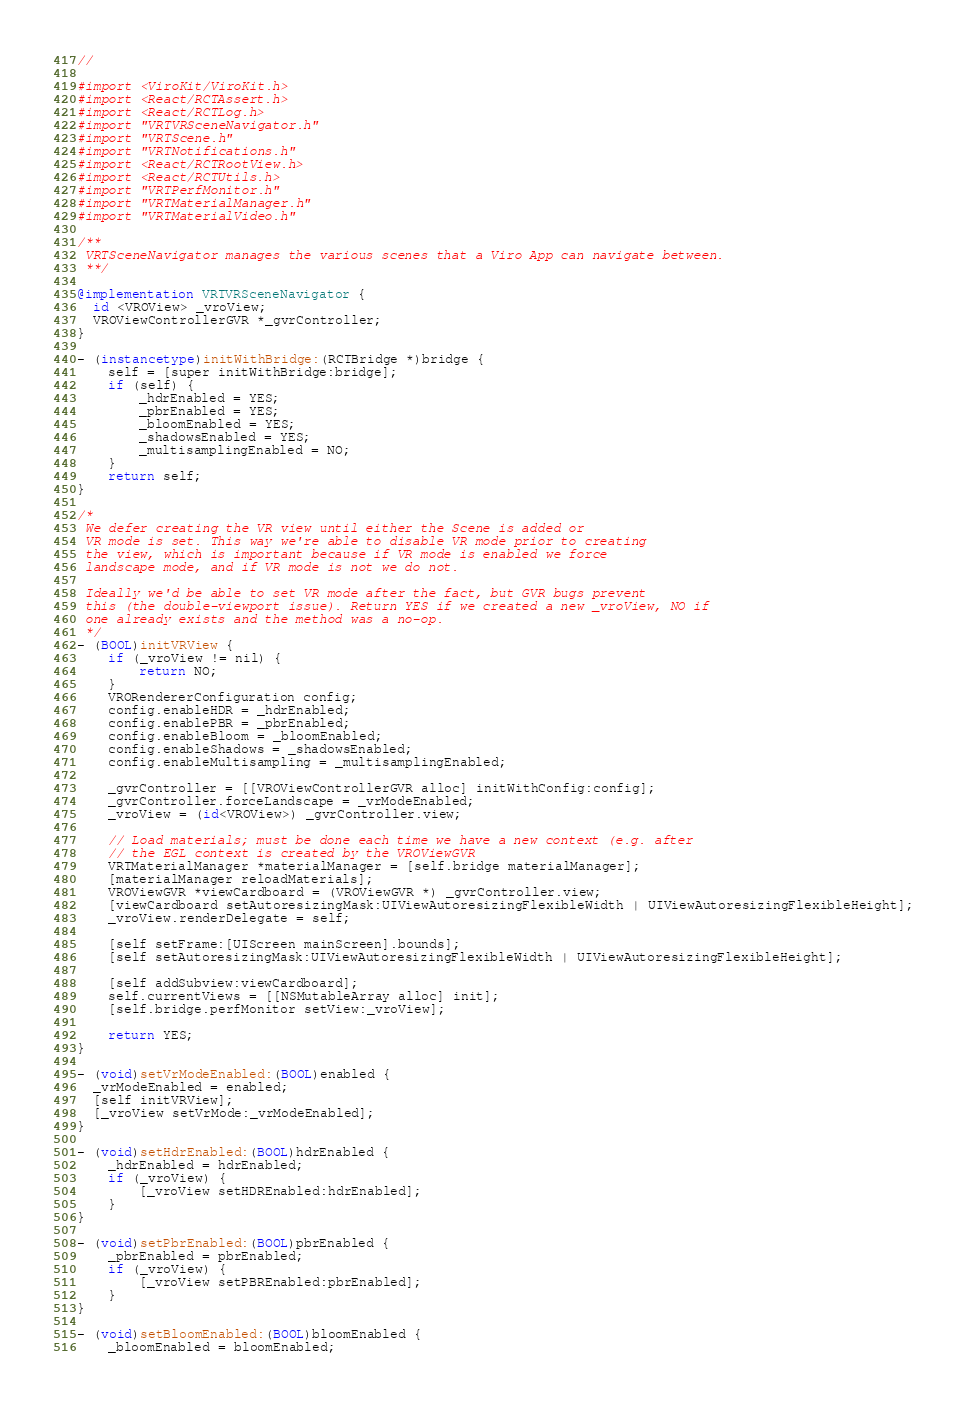<code> <loc_0><loc_0><loc_500><loc_500><_ObjectiveC_>//

#import <ViroKit/ViroKit.h>
#import <React/RCTAssert.h>
#import <React/RCTLog.h>
#import "VRTVRSceneNavigator.h"
#import "VRTScene.h"
#import "VRTNotifications.h"
#import <React/RCTRootView.h>
#import <React/RCTUtils.h>
#import "VRTPerfMonitor.h"
#import "VRTMaterialManager.h"
#import "VRTMaterialVideo.h"

/**
 VRTSceneNavigator manages the various scenes that a Viro App can navigate between.
 **/

@implementation VRTVRSceneNavigator {
  id <VROView> _vroView;
  VROViewControllerGVR *_gvrController;
}

- (instancetype)initWithBridge:(RCTBridge *)bridge {
    self = [super initWithBridge:bridge];
    if (self) {
        _hdrEnabled = YES;
        _pbrEnabled = YES;
        _bloomEnabled = YES;
        _shadowsEnabled = YES;
        _multisamplingEnabled = NO;
    }
    return self;
}

/*
 We defer creating the VR view until either the Scene is added or
 VR mode is set. This way we're able to disable VR mode prior to creating
 the view, which is important because if VR mode is enabled we force
 landscape mode, and if VR mode is not we do not.
 
 Ideally we'd be able to set VR mode after the fact, but GVR bugs prevent
 this (the double-viewport issue). Return YES if we created a new _vroView, NO if
 one already exists and the method was a no-op.
 */
- (BOOL)initVRView {
    if (_vroView != nil) {
        return NO;
    }
    VRORendererConfiguration config;
    config.enableHDR = _hdrEnabled;
    config.enablePBR = _pbrEnabled;
    config.enableBloom = _bloomEnabled;
    config.enableShadows = _shadowsEnabled;
    config.enableMultisampling = _multisamplingEnabled;
    
    _gvrController = [[VROViewControllerGVR alloc] initWithConfig:config];
    _gvrController.forceLandscape = _vrModeEnabled;
    _vroView = (id<VROView>) _gvrController.view;
    
    // Load materials; must be done each time we have a new context (e.g. after
    // the EGL context is created by the VROViewGVR
    VRTMaterialManager *materialManager = [self.bridge materialManager];
    [materialManager reloadMaterials];
    VROViewGVR *viewCardboard = (VROViewGVR *) _gvrController.view;
    [viewCardboard setAutoresizingMask:UIViewAutoresizingFlexibleWidth | UIViewAutoresizingFlexibleHeight];
    _vroView.renderDelegate = self;
    
    [self setFrame:[UIScreen mainScreen].bounds];
    [self setAutoresizingMask:UIViewAutoresizingFlexibleWidth | UIViewAutoresizingFlexibleHeight];
    
    [self addSubview:viewCardboard];
    self.currentViews = [[NSMutableArray alloc] init];
    [self.bridge.perfMonitor setView:_vroView];
    
    return YES;
}

- (void)setVrModeEnabled:(BOOL)enabled {
  _vrModeEnabled = enabled;
  [self initVRView];
  [_vroView setVrMode:_vrModeEnabled];
}

- (void)setHdrEnabled:(BOOL)hdrEnabled {
    _hdrEnabled = hdrEnabled;
    if (_vroView) {
        [_vroView setHDREnabled:hdrEnabled];
    }
}

- (void)setPbrEnabled:(BOOL)pbrEnabled {
    _pbrEnabled = pbrEnabled;
    if (_vroView) {
        [_vroView setPBREnabled:pbrEnabled];
    }
}

- (void)setBloomEnabled:(BOOL)bloomEnabled {
    _bloomEnabled = bloomEnabled;</code> 